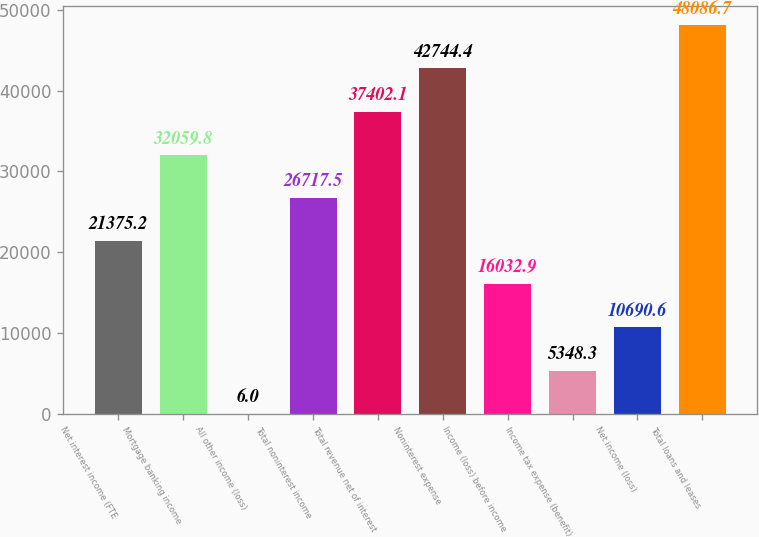Convert chart. <chart><loc_0><loc_0><loc_500><loc_500><bar_chart><fcel>Net interest income (FTE<fcel>Mortgage banking income<fcel>All other income (loss)<fcel>Total noninterest income<fcel>Total revenue net of interest<fcel>Noninterest expense<fcel>Income (loss) before income<fcel>Income tax expense (benefit)<fcel>Net income (loss)<fcel>Total loans and leases<nl><fcel>21375.2<fcel>32059.8<fcel>6<fcel>26717.5<fcel>37402.1<fcel>42744.4<fcel>16032.9<fcel>5348.3<fcel>10690.6<fcel>48086.7<nl></chart> 